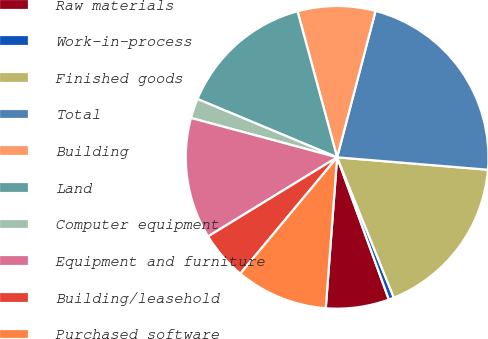<chart> <loc_0><loc_0><loc_500><loc_500><pie_chart><fcel>Raw materials<fcel>Work-in-process<fcel>Finished goods<fcel>Total<fcel>Building<fcel>Land<fcel>Computer equipment<fcel>Equipment and furniture<fcel>Building/leasehold<fcel>Purchased software<nl><fcel>6.75%<fcel>0.56%<fcel>17.58%<fcel>22.22%<fcel>8.3%<fcel>14.49%<fcel>2.11%<fcel>12.94%<fcel>5.2%<fcel>9.85%<nl></chart> 